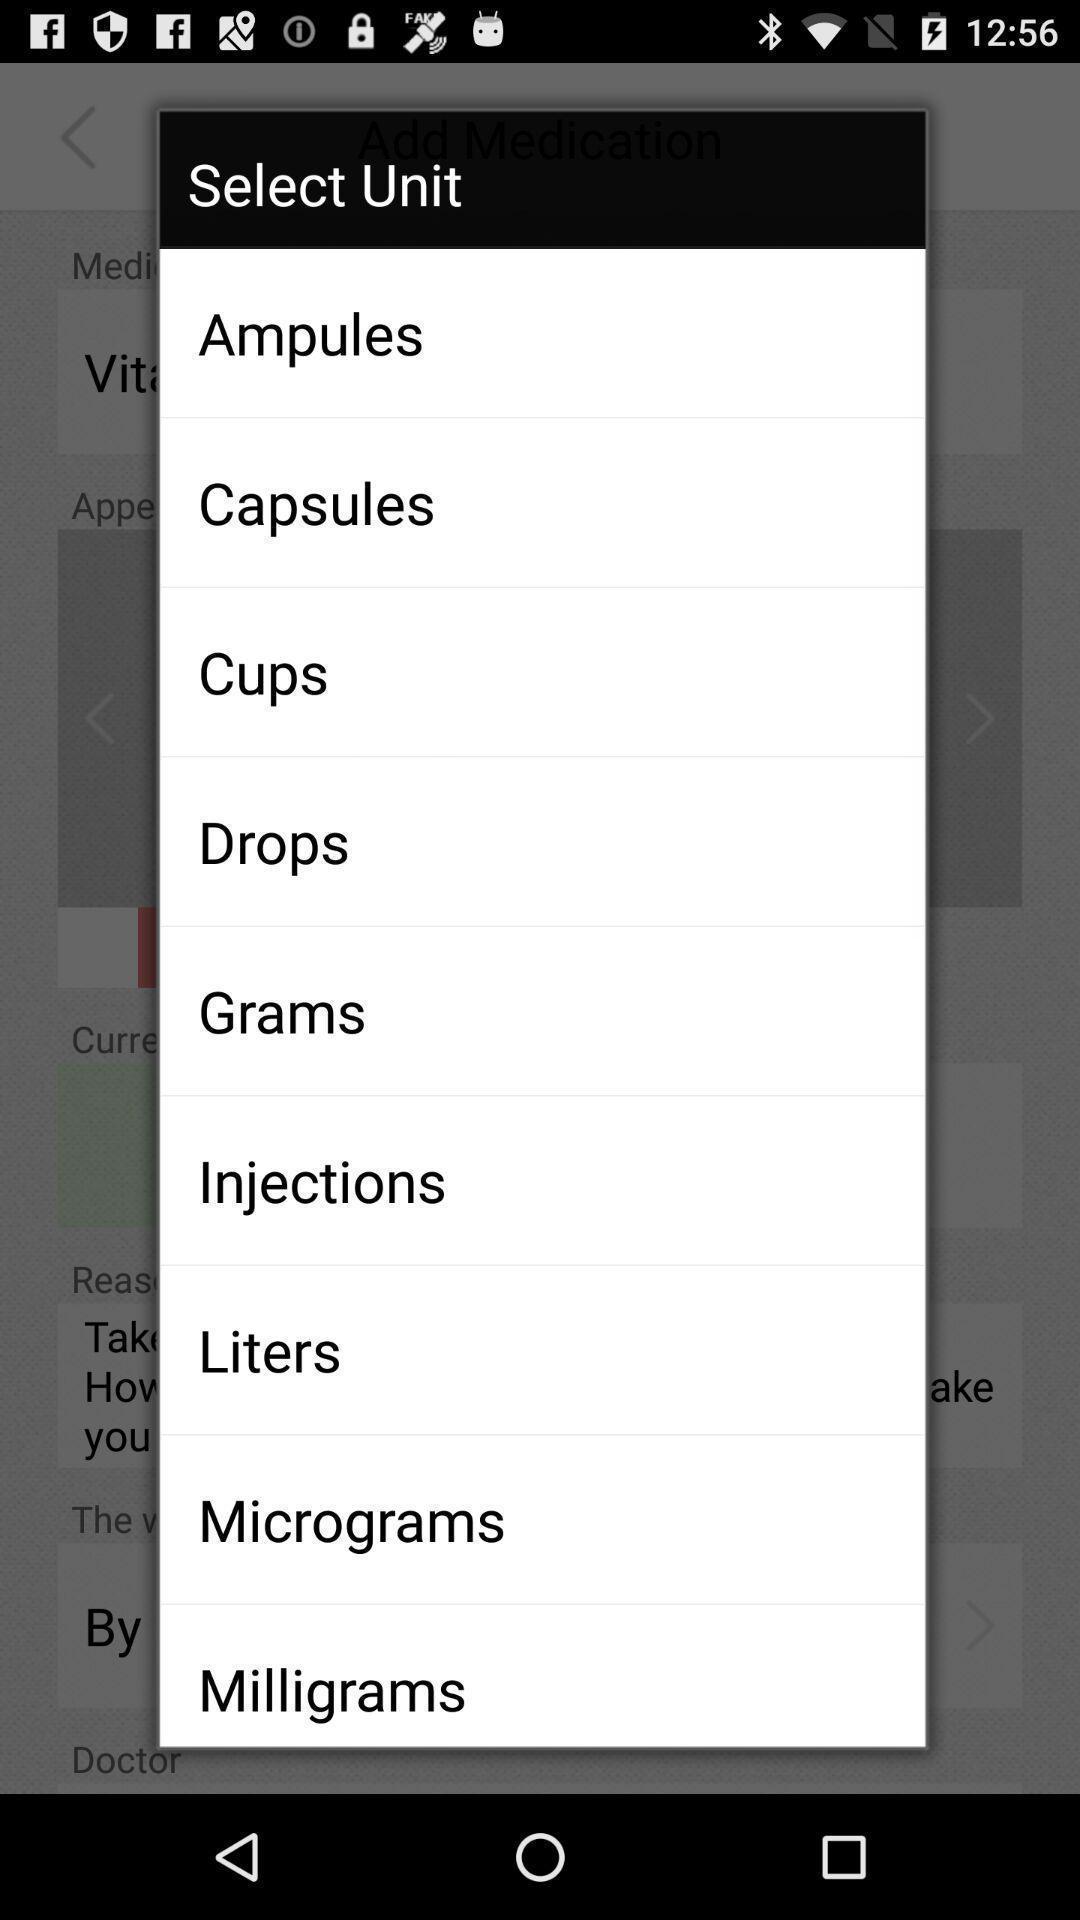Describe this image in words. Pop-up shows select unit list. 